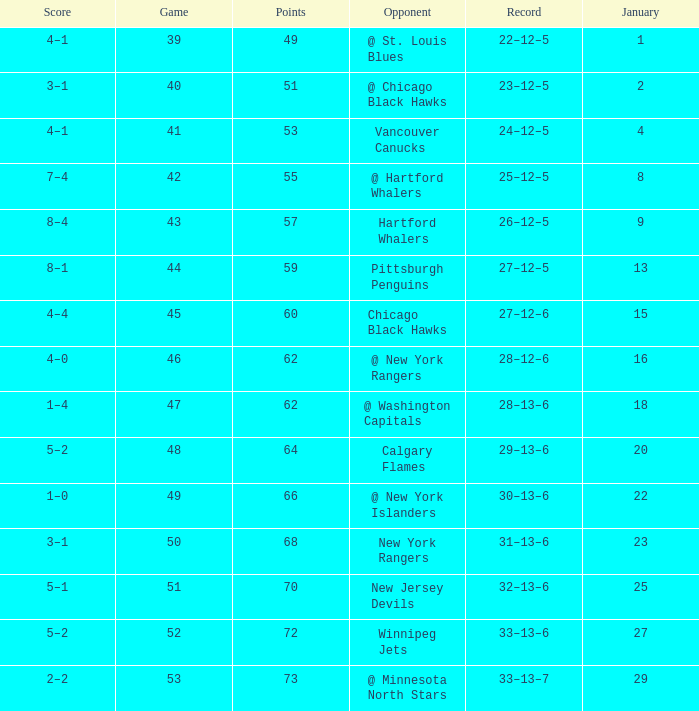How many games have a Score of 1–0, and Points smaller than 66? 0.0. 